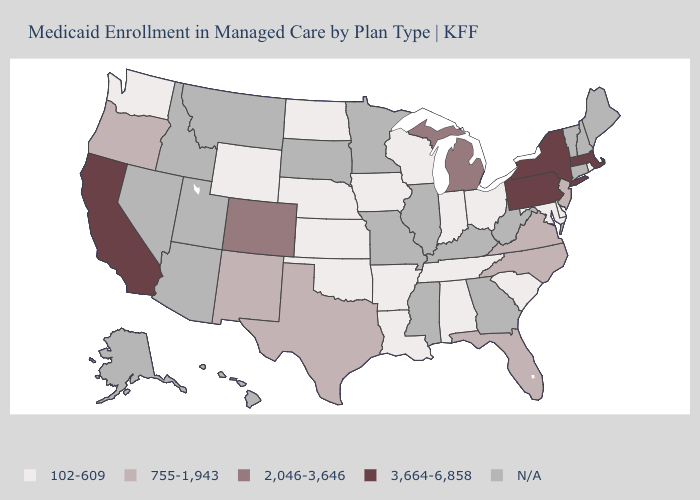Which states have the lowest value in the MidWest?
Give a very brief answer. Indiana, Iowa, Kansas, Nebraska, North Dakota, Ohio, Wisconsin. What is the highest value in states that border Tennessee?
Answer briefly. 755-1,943. What is the value of Wisconsin?
Short answer required. 102-609. What is the value of California?
Answer briefly. 3,664-6,858. What is the highest value in the USA?
Answer briefly. 3,664-6,858. Among the states that border New Jersey , which have the lowest value?
Concise answer only. Delaware. Does Wisconsin have the lowest value in the USA?
Be succinct. Yes. What is the lowest value in the USA?
Answer briefly. 102-609. Name the states that have a value in the range 3,664-6,858?
Give a very brief answer. California, Massachusetts, New York, Pennsylvania. Does the first symbol in the legend represent the smallest category?
Answer briefly. Yes. Which states have the highest value in the USA?
Answer briefly. California, Massachusetts, New York, Pennsylvania. Name the states that have a value in the range N/A?
Short answer required. Alaska, Arizona, Connecticut, Georgia, Hawaii, Idaho, Illinois, Kentucky, Maine, Minnesota, Mississippi, Missouri, Montana, Nevada, New Hampshire, South Dakota, Utah, Vermont, West Virginia. Is the legend a continuous bar?
Answer briefly. No. Name the states that have a value in the range 102-609?
Give a very brief answer. Alabama, Arkansas, Delaware, Indiana, Iowa, Kansas, Louisiana, Maryland, Nebraska, North Dakota, Ohio, Oklahoma, Rhode Island, South Carolina, Tennessee, Washington, Wisconsin, Wyoming. 